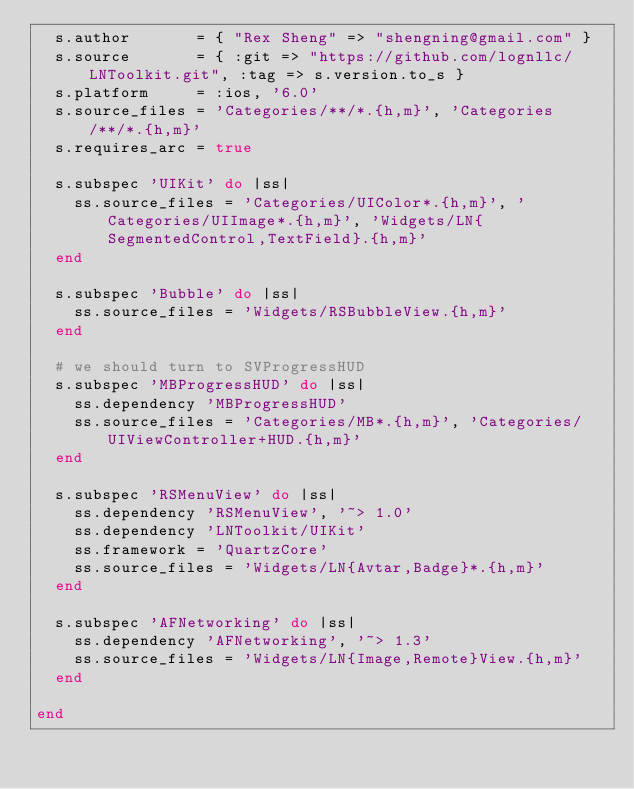<code> <loc_0><loc_0><loc_500><loc_500><_Ruby_>  s.author       = { "Rex Sheng" => "shengning@gmail.com" }
  s.source       = { :git => "https://github.com/lognllc/LNToolkit.git", :tag => s.version.to_s }
  s.platform     = :ios, '6.0'
  s.source_files = 'Categories/**/*.{h,m}', 'Categories/**/*.{h,m}'
  s.requires_arc = true

  s.subspec 'UIKit' do |ss|
    ss.source_files = 'Categories/UIColor*.{h,m}', 'Categories/UIImage*.{h,m}', 'Widgets/LN{SegmentedControl,TextField}.{h,m}'
  end
  
  s.subspec 'Bubble' do |ss|
    ss.source_files = 'Widgets/RSBubbleView.{h,m}'
  end
  
  # we should turn to SVProgressHUD
  s.subspec 'MBProgressHUD' do |ss|
    ss.dependency 'MBProgressHUD'
    ss.source_files = 'Categories/MB*.{h,m}', 'Categories/UIViewController+HUD.{h,m}'
  end
  
  s.subspec 'RSMenuView' do |ss|
    ss.dependency 'RSMenuView', '~> 1.0'
    ss.dependency 'LNToolkit/UIKit'
    ss.framework = 'QuartzCore'
    ss.source_files = 'Widgets/LN{Avtar,Badge}*.{h,m}'
  end
  
  s.subspec 'AFNetworking' do |ss|
    ss.dependency 'AFNetworking', '~> 1.3'
    ss.source_files = 'Widgets/LN{Image,Remote}View.{h,m}'
  end

end
</code> 